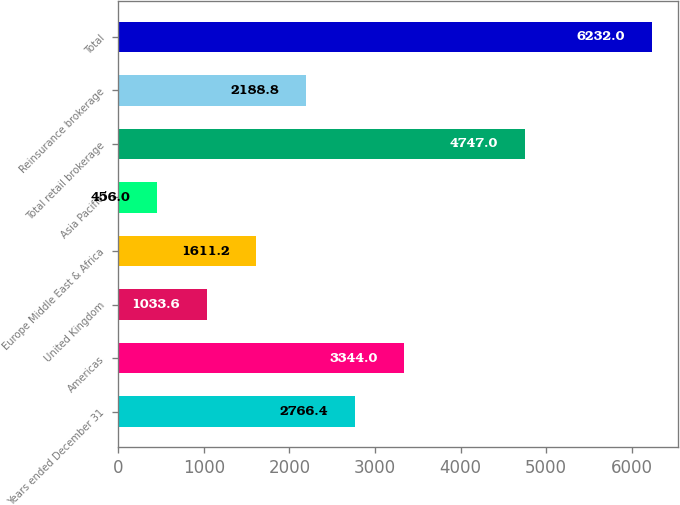Convert chart to OTSL. <chart><loc_0><loc_0><loc_500><loc_500><bar_chart><fcel>Years ended December 31<fcel>Americas<fcel>United Kingdom<fcel>Europe Middle East & Africa<fcel>Asia Pacific<fcel>Total retail brokerage<fcel>Reinsurance brokerage<fcel>Total<nl><fcel>2766.4<fcel>3344<fcel>1033.6<fcel>1611.2<fcel>456<fcel>4747<fcel>2188.8<fcel>6232<nl></chart> 